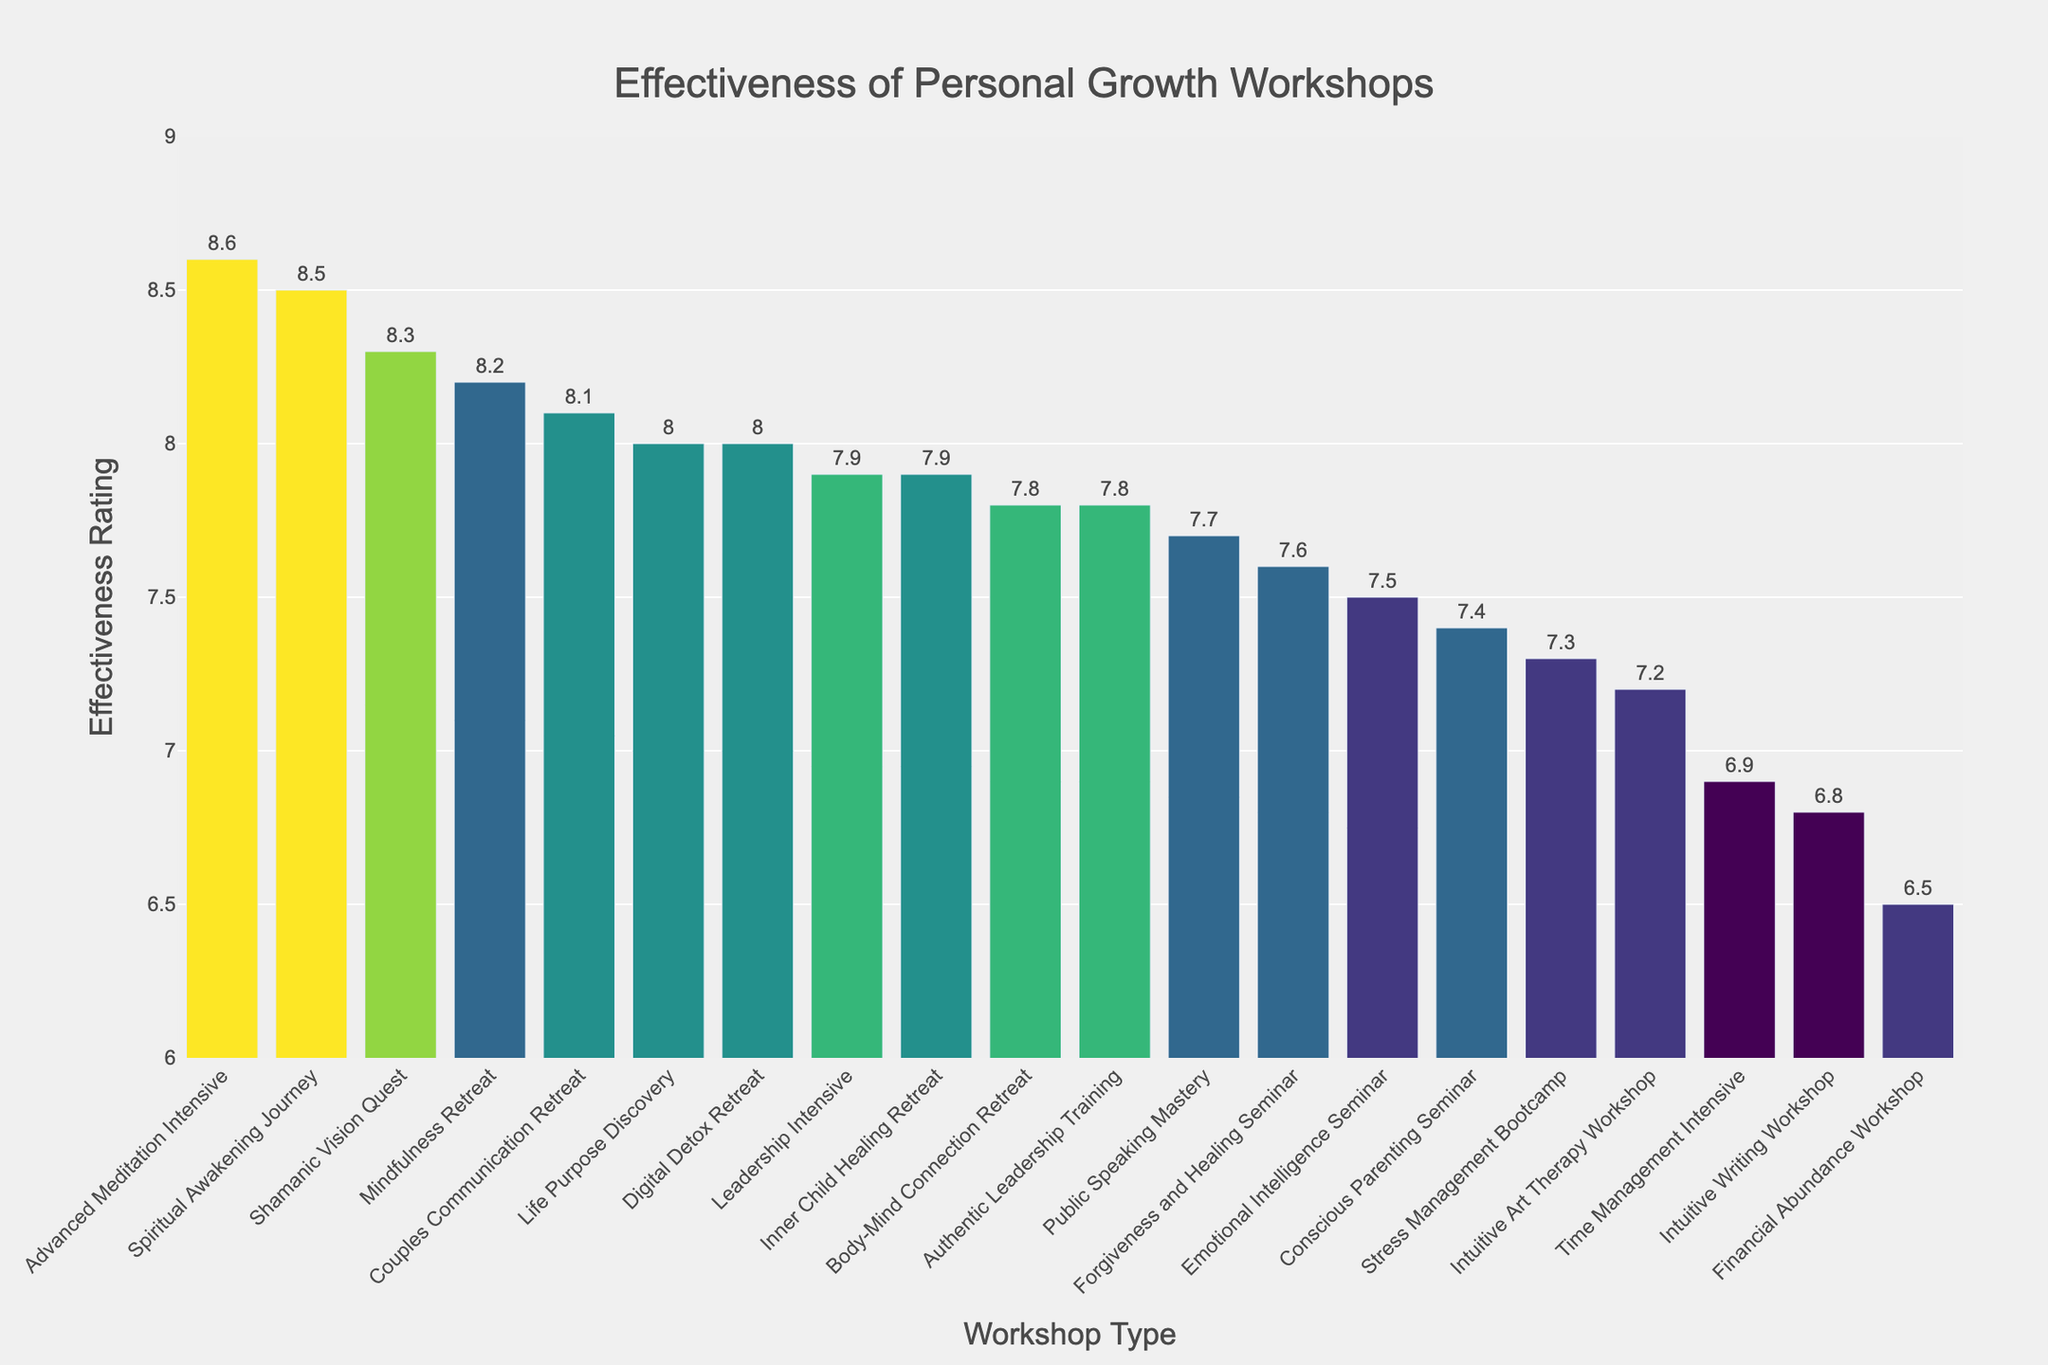Which workshop has the highest effectiveness rating? Looking at the figure, the tallest bar represents the workshop with the highest rating. The "Advanced Meditation Intensive" workshop has the highest rating.
Answer: Advanced Meditation Intensive What is the difference in effectiveness rating between the "Intuitive Writing Workshop" and the "Financial Abundance Workshop"? Locate the bars for each workshop and note their ratings. "Intuitive Writing Workshop" has a rating of 6.8, and "Financial Abundance Workshop" has a rating of 6.5. The difference is 6.8 - 6.5 = 0.3.
Answer: 0.3 How many workshops have a duration of 4 days and what are their average effectiveness ratings? Identify the bars colored similarly, representing a 4-day duration, and note their effectiveness ratings. The workshops with 4-day durations are "Couples Communication Retreat" (8.1), "Life Purpose Discovery" (8.0), "Digital Detox Retreat" (8.0), and "Inner Child Healing Retreat" (7.9). Their average rating is (8.1 + 8.0 + 8.0 + 7.9)/4 = 8.0.
Answer: 4, 8.0 Which workshop focusing on Meditation has the highest effectiveness rating? Look for workshops that focus on Meditation and compare their ratings. The possible candidates are "Mindfulness Retreat" (8.2) and "Advanced Meditation Intensive" (8.6). "Advanced Meditation Intensive" has the higher rating.
Answer: Advanced Meditation Intensive What is the average effectiveness rating of workshops with a duration greater than 3 days? Identify the bars with durations of more than 3 days and calculate their ratings. The workshops are "Leadership Intensive" (7.9), "Body-Mind Connection Retreat" (7.8), "Shamanic Vision Quest" (8.3), "Spiritual Awakening Journey" (8.5), "Inner Child Healing Retreat" (7.9), "Couples Communication Retreat" (8.1), "Life Purpose Discovery" (8.0), "Digital Detox Retreat" (8.0), "Advanced Meditation Intensive" (8.6), and "Authentic Leadership Training" (7.8). The average rating is (7.9 + 7.8 + 8.3 + 8.5 + 7.9 + 8.1 + 8.0 + 8.0 + 8.6 + 7.8)/10 = 8.09.
Answer: 8.09 Which workshop has the lowest effectiveness rating and what is its focus area? Find the shortest bar in the figure to identify the lowest rating. The "Financial Abundance Workshop" has the lowest rating, and its focus area is "Wealth".
Answer: Financial Abundance Workshop, Wealth Compare the effectiveness ratings of the "Emotional Intelligence Seminar" and the "Public Speaking Mastery". Which one is higher? Note the ratings of both workshops: "Emotional Intelligence Seminar" has 7.5 and "Public Speaking Mastery" has 7.7. The "Public Speaking Mastery" rating is higher.
Answer: Public Speaking Mastery What are the colors associated with workshops lasting 7 days, and how do these colors compared to those with the shortest duration? Observing the color scale, the workshops with a 7-day duration should have a distinct dark color due to longer duration. The workshops with 7-day durations are "Spiritual Awakening Journey" and "Advanced Meditation Intensive", which are darker hues. The shortest duration, 1 day, appears in lighter hues associated with "Intuitive Writing Workshop" and "Time Management Intensive".
Answer: Darker hues versus lighter hues How many workshops focus on Spirituality, and what is their average effectiveness rating? Identify workshops focusing on Spirituality. The relevant workshops are "Spiritual Awakening Journey" (8.5) and "Shamanic Vision Quest" (8.3). Their average rating is (8.5 + 8.3)/2 = 8.4.
Answer: 2, 8.4 Identify the focus area with the most workshops and find the average effectiveness rating for this area. By counting the number of workshops in each focus area, we can see that no single focus area dominates numerically. However, areas like "Spirituality" have more impactful presences due to high ratings.
Answer: Various; Spirituality has high impact 